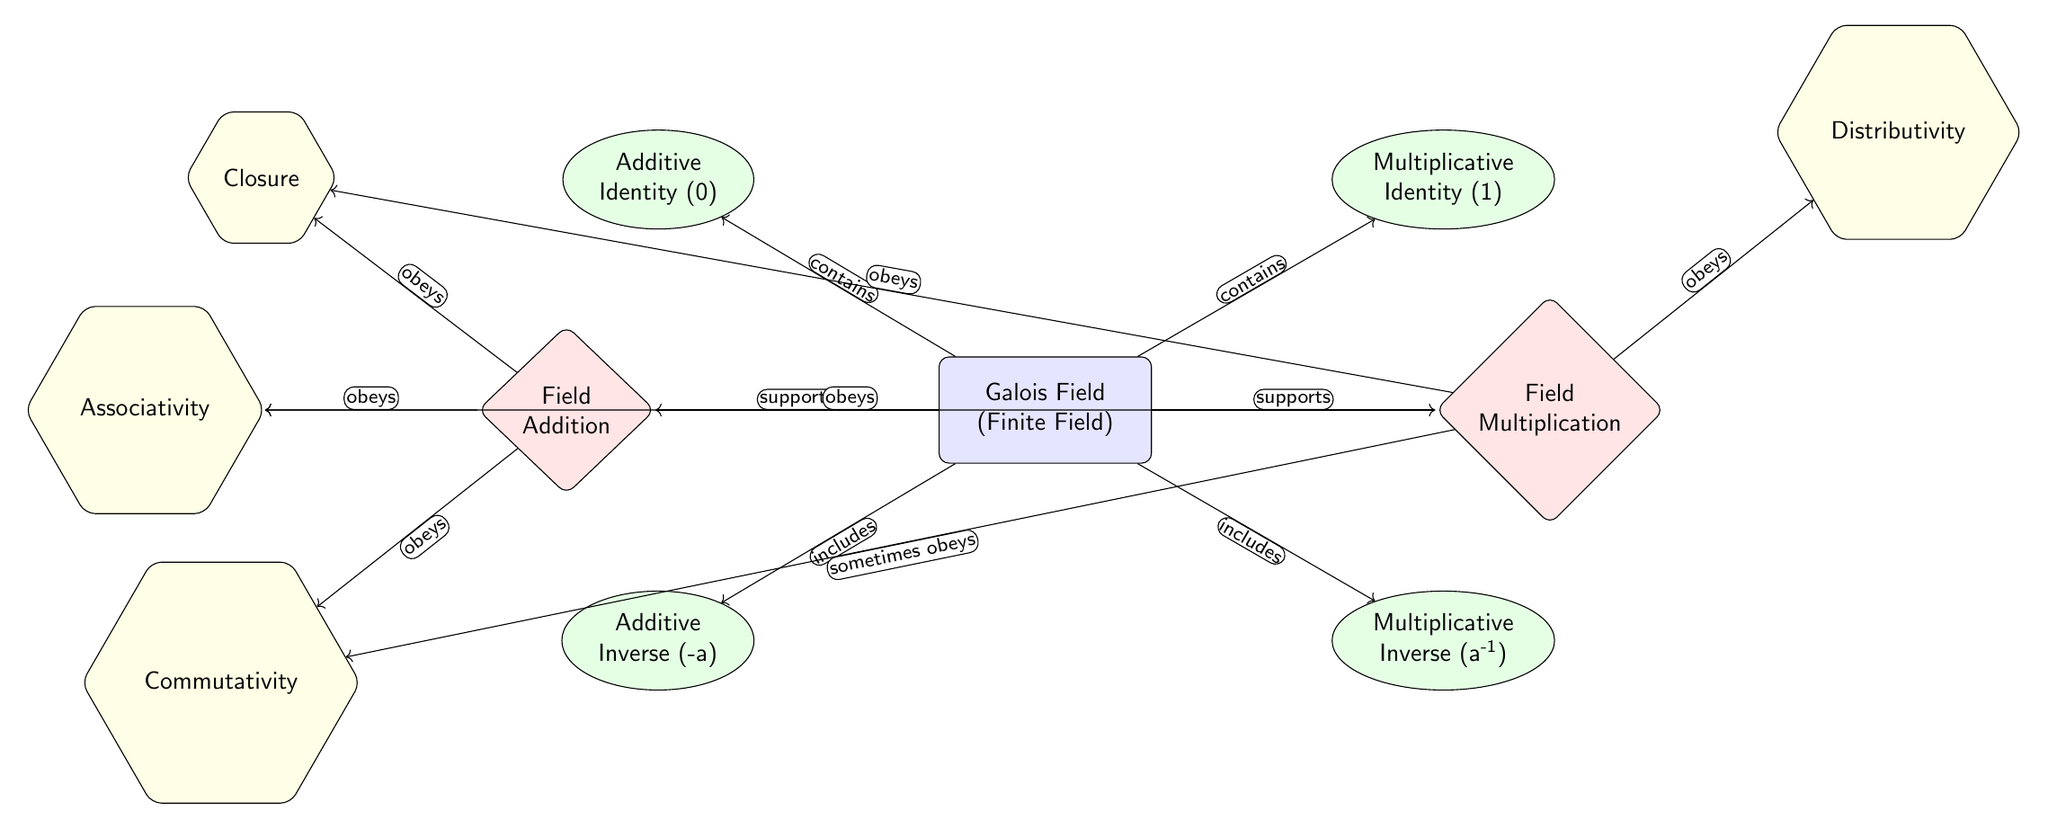What is the node representing the Additive Identity? The diagram shows the node labeled "Additive Identity" located toward the top left of the Galois Field node. This node indicates the value that acts as the additive identity, which is 0 in this context.
Answer: Additive Identity (0) How many nodes are contained within the Galois Field node? In the diagram, the Galois Field node is connected to four properties (Additive Identity, Multiplicative Identity, Additive Inverse, Multiplicative Inverse) and two operations (Field Addition, Field Multiplication), making a total of six nodes.
Answer: 6 What is the relationship between Field Addition and Closure? The diagram indicates that Field Addition 'obeys' the property of Closure as shown by the directed arrow connecting these two nodes. This means that the result of adding any two elements from the field will also belong to the field, satisfying the closure property.
Answer: obeys Which property sometimes holds for Field Multiplication regarding Commutativity? The diagram displays that Field Multiplication 'sometimes obeys' the property of Commutativity, as denoted by the unique label on the edge connecting these two nodes. This indicates that multiplication of certain elements may not always be commutative in the context of this finite field.
Answer: sometimes obeys What is the value associated with the Multiplicative Identity node? The diagram shows that the Multiplicative Identity node refers to the identity element for multiplication in a finite field, which is universally recognized as 1.
Answer: Multiplicative Identity (1) Which law is directly related to the operation of Field Multiplication mentioned in the diagram? According to the diagram, Field Multiplication directly relates to the law of Distributivity as indicated by the directed arrow connecting them. This suggests that multiplication distributively interacts with addition in the field.
Answer: Distributivity 